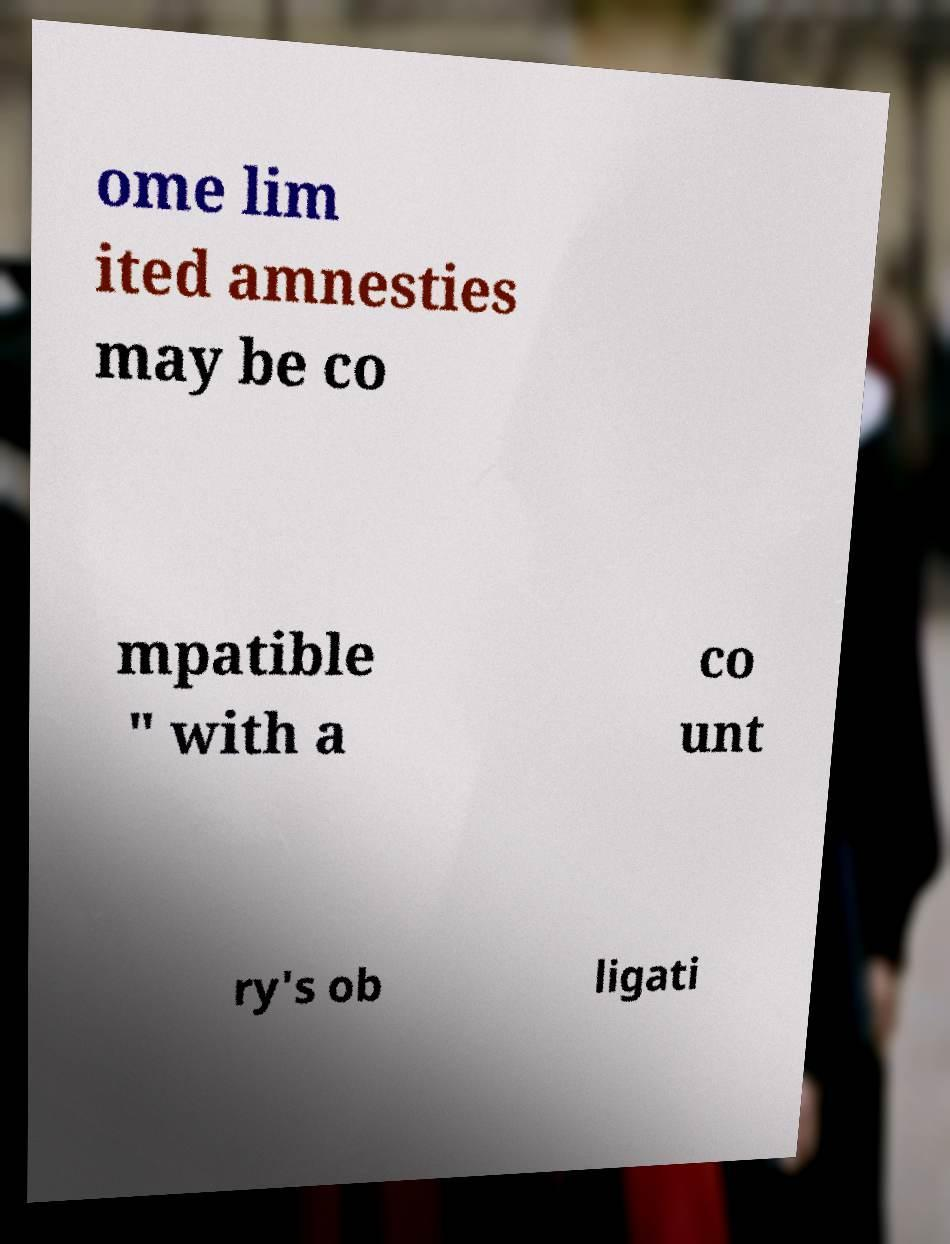Could you extract and type out the text from this image? ome lim ited amnesties may be co mpatible " with a co unt ry's ob ligati 